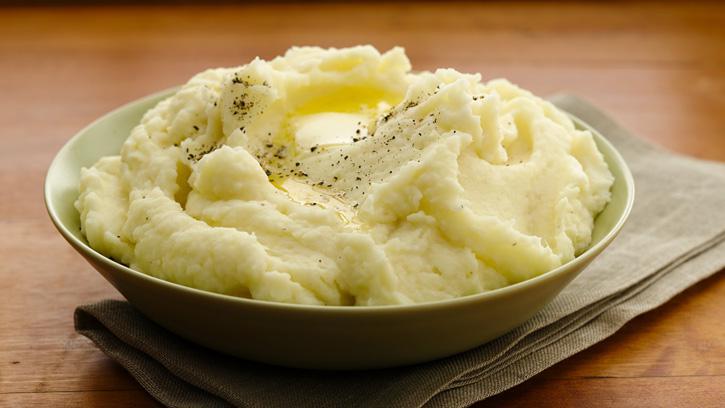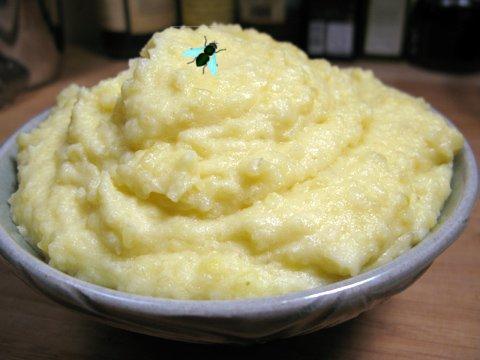The first image is the image on the left, the second image is the image on the right. For the images displayed, is the sentence "One image shows potatoes in a pot of water before boiling." factually correct? Answer yes or no. No. 